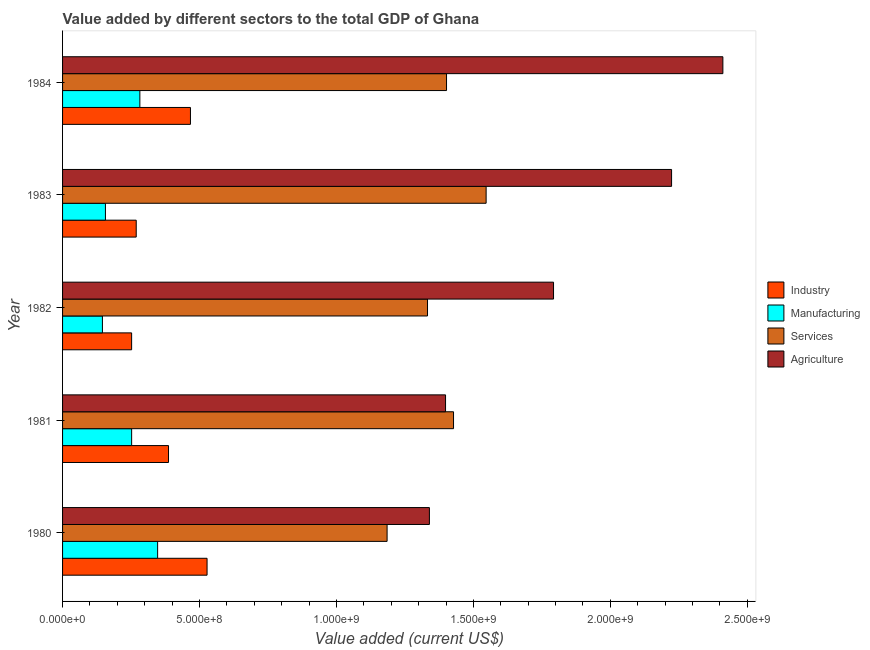How many groups of bars are there?
Ensure brevity in your answer.  5. Are the number of bars on each tick of the Y-axis equal?
Offer a terse response. Yes. How many bars are there on the 4th tick from the bottom?
Provide a short and direct response. 4. What is the label of the 4th group of bars from the top?
Your response must be concise. 1981. In how many cases, is the number of bars for a given year not equal to the number of legend labels?
Ensure brevity in your answer.  0. What is the value added by manufacturing sector in 1981?
Provide a succinct answer. 2.52e+08. Across all years, what is the maximum value added by industrial sector?
Your answer should be very brief. 5.28e+08. Across all years, what is the minimum value added by industrial sector?
Ensure brevity in your answer.  2.52e+08. In which year was the value added by agricultural sector maximum?
Your answer should be very brief. 1984. In which year was the value added by manufacturing sector minimum?
Provide a succinct answer. 1982. What is the total value added by manufacturing sector in the graph?
Make the answer very short. 1.18e+09. What is the difference between the value added by services sector in 1980 and that in 1984?
Your response must be concise. -2.17e+08. What is the difference between the value added by industrial sector in 1980 and the value added by manufacturing sector in 1983?
Give a very brief answer. 3.71e+08. What is the average value added by manufacturing sector per year?
Your response must be concise. 2.37e+08. In the year 1980, what is the difference between the value added by manufacturing sector and value added by services sector?
Your response must be concise. -8.38e+08. What is the ratio of the value added by industrial sector in 1981 to that in 1983?
Make the answer very short. 1.44. Is the value added by agricultural sector in 1982 less than that in 1983?
Offer a very short reply. Yes. Is the difference between the value added by industrial sector in 1980 and 1983 greater than the difference between the value added by services sector in 1980 and 1983?
Give a very brief answer. Yes. What is the difference between the highest and the second highest value added by services sector?
Make the answer very short. 1.19e+08. What is the difference between the highest and the lowest value added by services sector?
Provide a short and direct response. 3.62e+08. Is it the case that in every year, the sum of the value added by manufacturing sector and value added by industrial sector is greater than the sum of value added by services sector and value added by agricultural sector?
Provide a short and direct response. No. What does the 2nd bar from the top in 1980 represents?
Your response must be concise. Services. What does the 3rd bar from the bottom in 1983 represents?
Keep it short and to the point. Services. Is it the case that in every year, the sum of the value added by industrial sector and value added by manufacturing sector is greater than the value added by services sector?
Your answer should be compact. No. How many years are there in the graph?
Ensure brevity in your answer.  5. What is the difference between two consecutive major ticks on the X-axis?
Your answer should be compact. 5.00e+08. Are the values on the major ticks of X-axis written in scientific E-notation?
Offer a terse response. Yes. How many legend labels are there?
Your response must be concise. 4. What is the title of the graph?
Make the answer very short. Value added by different sectors to the total GDP of Ghana. Does "WHO" appear as one of the legend labels in the graph?
Give a very brief answer. No. What is the label or title of the X-axis?
Offer a terse response. Value added (current US$). What is the label or title of the Y-axis?
Offer a terse response. Year. What is the Value added (current US$) in Industry in 1980?
Offer a very short reply. 5.28e+08. What is the Value added (current US$) in Manufacturing in 1980?
Provide a succinct answer. 3.47e+08. What is the Value added (current US$) of Services in 1980?
Keep it short and to the point. 1.18e+09. What is the Value added (current US$) of Agriculture in 1980?
Your response must be concise. 1.34e+09. What is the Value added (current US$) of Industry in 1981?
Ensure brevity in your answer.  3.87e+08. What is the Value added (current US$) in Manufacturing in 1981?
Make the answer very short. 2.52e+08. What is the Value added (current US$) in Services in 1981?
Ensure brevity in your answer.  1.43e+09. What is the Value added (current US$) of Agriculture in 1981?
Your answer should be compact. 1.40e+09. What is the Value added (current US$) in Industry in 1982?
Ensure brevity in your answer.  2.52e+08. What is the Value added (current US$) of Manufacturing in 1982?
Give a very brief answer. 1.46e+08. What is the Value added (current US$) of Services in 1982?
Provide a succinct answer. 1.33e+09. What is the Value added (current US$) of Agriculture in 1982?
Your response must be concise. 1.79e+09. What is the Value added (current US$) of Industry in 1983?
Offer a very short reply. 2.69e+08. What is the Value added (current US$) in Manufacturing in 1983?
Your response must be concise. 1.57e+08. What is the Value added (current US$) of Services in 1983?
Ensure brevity in your answer.  1.55e+09. What is the Value added (current US$) in Agriculture in 1983?
Give a very brief answer. 2.22e+09. What is the Value added (current US$) of Industry in 1984?
Provide a short and direct response. 4.67e+08. What is the Value added (current US$) in Manufacturing in 1984?
Offer a very short reply. 2.82e+08. What is the Value added (current US$) in Services in 1984?
Provide a succinct answer. 1.40e+09. What is the Value added (current US$) in Agriculture in 1984?
Provide a succinct answer. 2.41e+09. Across all years, what is the maximum Value added (current US$) of Industry?
Provide a succinct answer. 5.28e+08. Across all years, what is the maximum Value added (current US$) of Manufacturing?
Your response must be concise. 3.47e+08. Across all years, what is the maximum Value added (current US$) of Services?
Offer a terse response. 1.55e+09. Across all years, what is the maximum Value added (current US$) of Agriculture?
Your answer should be very brief. 2.41e+09. Across all years, what is the minimum Value added (current US$) in Industry?
Keep it short and to the point. 2.52e+08. Across all years, what is the minimum Value added (current US$) of Manufacturing?
Your answer should be very brief. 1.46e+08. Across all years, what is the minimum Value added (current US$) in Services?
Give a very brief answer. 1.18e+09. Across all years, what is the minimum Value added (current US$) of Agriculture?
Ensure brevity in your answer.  1.34e+09. What is the total Value added (current US$) in Industry in the graph?
Make the answer very short. 1.90e+09. What is the total Value added (current US$) of Manufacturing in the graph?
Provide a short and direct response. 1.18e+09. What is the total Value added (current US$) of Services in the graph?
Provide a short and direct response. 6.89e+09. What is the total Value added (current US$) in Agriculture in the graph?
Your answer should be very brief. 9.16e+09. What is the difference between the Value added (current US$) of Industry in 1980 and that in 1981?
Give a very brief answer. 1.41e+08. What is the difference between the Value added (current US$) of Manufacturing in 1980 and that in 1981?
Your answer should be very brief. 9.49e+07. What is the difference between the Value added (current US$) in Services in 1980 and that in 1981?
Provide a succinct answer. -2.43e+08. What is the difference between the Value added (current US$) of Agriculture in 1980 and that in 1981?
Your answer should be very brief. -5.89e+07. What is the difference between the Value added (current US$) of Industry in 1980 and that in 1982?
Give a very brief answer. 2.75e+08. What is the difference between the Value added (current US$) in Manufacturing in 1980 and that in 1982?
Your answer should be compact. 2.02e+08. What is the difference between the Value added (current US$) in Services in 1980 and that in 1982?
Provide a short and direct response. -1.48e+08. What is the difference between the Value added (current US$) in Agriculture in 1980 and that in 1982?
Provide a succinct answer. -4.53e+08. What is the difference between the Value added (current US$) of Industry in 1980 and that in 1983?
Offer a very short reply. 2.59e+08. What is the difference between the Value added (current US$) of Manufacturing in 1980 and that in 1983?
Offer a terse response. 1.91e+08. What is the difference between the Value added (current US$) in Services in 1980 and that in 1983?
Your answer should be compact. -3.62e+08. What is the difference between the Value added (current US$) in Agriculture in 1980 and that in 1983?
Ensure brevity in your answer.  -8.84e+08. What is the difference between the Value added (current US$) of Industry in 1980 and that in 1984?
Your response must be concise. 6.07e+07. What is the difference between the Value added (current US$) of Manufacturing in 1980 and that in 1984?
Offer a terse response. 6.49e+07. What is the difference between the Value added (current US$) of Services in 1980 and that in 1984?
Provide a succinct answer. -2.17e+08. What is the difference between the Value added (current US$) in Agriculture in 1980 and that in 1984?
Ensure brevity in your answer.  -1.07e+09. What is the difference between the Value added (current US$) in Industry in 1981 and that in 1982?
Your response must be concise. 1.35e+08. What is the difference between the Value added (current US$) of Manufacturing in 1981 and that in 1982?
Your answer should be very brief. 1.07e+08. What is the difference between the Value added (current US$) of Services in 1981 and that in 1982?
Make the answer very short. 9.50e+07. What is the difference between the Value added (current US$) in Agriculture in 1981 and that in 1982?
Ensure brevity in your answer.  -3.94e+08. What is the difference between the Value added (current US$) of Industry in 1981 and that in 1983?
Keep it short and to the point. 1.18e+08. What is the difference between the Value added (current US$) of Manufacturing in 1981 and that in 1983?
Ensure brevity in your answer.  9.57e+07. What is the difference between the Value added (current US$) of Services in 1981 and that in 1983?
Keep it short and to the point. -1.19e+08. What is the difference between the Value added (current US$) in Agriculture in 1981 and that in 1983?
Make the answer very short. -8.25e+08. What is the difference between the Value added (current US$) in Industry in 1981 and that in 1984?
Give a very brief answer. -8.01e+07. What is the difference between the Value added (current US$) in Manufacturing in 1981 and that in 1984?
Offer a very short reply. -3.00e+07. What is the difference between the Value added (current US$) of Services in 1981 and that in 1984?
Keep it short and to the point. 2.55e+07. What is the difference between the Value added (current US$) of Agriculture in 1981 and that in 1984?
Keep it short and to the point. -1.01e+09. What is the difference between the Value added (current US$) of Industry in 1982 and that in 1983?
Ensure brevity in your answer.  -1.68e+07. What is the difference between the Value added (current US$) in Manufacturing in 1982 and that in 1983?
Provide a short and direct response. -1.10e+07. What is the difference between the Value added (current US$) of Services in 1982 and that in 1983?
Offer a very short reply. -2.14e+08. What is the difference between the Value added (current US$) in Agriculture in 1982 and that in 1983?
Make the answer very short. -4.31e+08. What is the difference between the Value added (current US$) of Industry in 1982 and that in 1984?
Keep it short and to the point. -2.15e+08. What is the difference between the Value added (current US$) of Manufacturing in 1982 and that in 1984?
Your answer should be compact. -1.37e+08. What is the difference between the Value added (current US$) of Services in 1982 and that in 1984?
Provide a short and direct response. -6.95e+07. What is the difference between the Value added (current US$) in Agriculture in 1982 and that in 1984?
Keep it short and to the point. -6.18e+08. What is the difference between the Value added (current US$) in Industry in 1983 and that in 1984?
Keep it short and to the point. -1.98e+08. What is the difference between the Value added (current US$) in Manufacturing in 1983 and that in 1984?
Provide a short and direct response. -1.26e+08. What is the difference between the Value added (current US$) of Services in 1983 and that in 1984?
Ensure brevity in your answer.  1.45e+08. What is the difference between the Value added (current US$) in Agriculture in 1983 and that in 1984?
Your answer should be compact. -1.87e+08. What is the difference between the Value added (current US$) of Industry in 1980 and the Value added (current US$) of Manufacturing in 1981?
Keep it short and to the point. 2.75e+08. What is the difference between the Value added (current US$) in Industry in 1980 and the Value added (current US$) in Services in 1981?
Provide a succinct answer. -9.00e+08. What is the difference between the Value added (current US$) of Industry in 1980 and the Value added (current US$) of Agriculture in 1981?
Keep it short and to the point. -8.71e+08. What is the difference between the Value added (current US$) of Manufacturing in 1980 and the Value added (current US$) of Services in 1981?
Ensure brevity in your answer.  -1.08e+09. What is the difference between the Value added (current US$) of Manufacturing in 1980 and the Value added (current US$) of Agriculture in 1981?
Your response must be concise. -1.05e+09. What is the difference between the Value added (current US$) of Services in 1980 and the Value added (current US$) of Agriculture in 1981?
Provide a succinct answer. -2.13e+08. What is the difference between the Value added (current US$) of Industry in 1980 and the Value added (current US$) of Manufacturing in 1982?
Make the answer very short. 3.82e+08. What is the difference between the Value added (current US$) of Industry in 1980 and the Value added (current US$) of Services in 1982?
Keep it short and to the point. -8.05e+08. What is the difference between the Value added (current US$) of Industry in 1980 and the Value added (current US$) of Agriculture in 1982?
Make the answer very short. -1.26e+09. What is the difference between the Value added (current US$) in Manufacturing in 1980 and the Value added (current US$) in Services in 1982?
Your answer should be very brief. -9.85e+08. What is the difference between the Value added (current US$) in Manufacturing in 1980 and the Value added (current US$) in Agriculture in 1982?
Provide a short and direct response. -1.45e+09. What is the difference between the Value added (current US$) in Services in 1980 and the Value added (current US$) in Agriculture in 1982?
Make the answer very short. -6.08e+08. What is the difference between the Value added (current US$) of Industry in 1980 and the Value added (current US$) of Manufacturing in 1983?
Provide a succinct answer. 3.71e+08. What is the difference between the Value added (current US$) in Industry in 1980 and the Value added (current US$) in Services in 1983?
Make the answer very short. -1.02e+09. What is the difference between the Value added (current US$) in Industry in 1980 and the Value added (current US$) in Agriculture in 1983?
Ensure brevity in your answer.  -1.70e+09. What is the difference between the Value added (current US$) in Manufacturing in 1980 and the Value added (current US$) in Services in 1983?
Give a very brief answer. -1.20e+09. What is the difference between the Value added (current US$) in Manufacturing in 1980 and the Value added (current US$) in Agriculture in 1983?
Your response must be concise. -1.88e+09. What is the difference between the Value added (current US$) in Services in 1980 and the Value added (current US$) in Agriculture in 1983?
Make the answer very short. -1.04e+09. What is the difference between the Value added (current US$) in Industry in 1980 and the Value added (current US$) in Manufacturing in 1984?
Provide a succinct answer. 2.45e+08. What is the difference between the Value added (current US$) of Industry in 1980 and the Value added (current US$) of Services in 1984?
Provide a short and direct response. -8.74e+08. What is the difference between the Value added (current US$) of Industry in 1980 and the Value added (current US$) of Agriculture in 1984?
Your answer should be very brief. -1.88e+09. What is the difference between the Value added (current US$) of Manufacturing in 1980 and the Value added (current US$) of Services in 1984?
Make the answer very short. -1.05e+09. What is the difference between the Value added (current US$) of Manufacturing in 1980 and the Value added (current US$) of Agriculture in 1984?
Make the answer very short. -2.06e+09. What is the difference between the Value added (current US$) in Services in 1980 and the Value added (current US$) in Agriculture in 1984?
Your answer should be compact. -1.23e+09. What is the difference between the Value added (current US$) in Industry in 1981 and the Value added (current US$) in Manufacturing in 1982?
Offer a terse response. 2.41e+08. What is the difference between the Value added (current US$) in Industry in 1981 and the Value added (current US$) in Services in 1982?
Your answer should be very brief. -9.46e+08. What is the difference between the Value added (current US$) in Industry in 1981 and the Value added (current US$) in Agriculture in 1982?
Your answer should be compact. -1.41e+09. What is the difference between the Value added (current US$) in Manufacturing in 1981 and the Value added (current US$) in Services in 1982?
Your answer should be compact. -1.08e+09. What is the difference between the Value added (current US$) in Manufacturing in 1981 and the Value added (current US$) in Agriculture in 1982?
Your answer should be very brief. -1.54e+09. What is the difference between the Value added (current US$) of Services in 1981 and the Value added (current US$) of Agriculture in 1982?
Offer a terse response. -3.65e+08. What is the difference between the Value added (current US$) in Industry in 1981 and the Value added (current US$) in Manufacturing in 1983?
Your answer should be compact. 2.30e+08. What is the difference between the Value added (current US$) of Industry in 1981 and the Value added (current US$) of Services in 1983?
Keep it short and to the point. -1.16e+09. What is the difference between the Value added (current US$) in Industry in 1981 and the Value added (current US$) in Agriculture in 1983?
Your answer should be compact. -1.84e+09. What is the difference between the Value added (current US$) of Manufacturing in 1981 and the Value added (current US$) of Services in 1983?
Your answer should be compact. -1.29e+09. What is the difference between the Value added (current US$) in Manufacturing in 1981 and the Value added (current US$) in Agriculture in 1983?
Your response must be concise. -1.97e+09. What is the difference between the Value added (current US$) of Services in 1981 and the Value added (current US$) of Agriculture in 1983?
Give a very brief answer. -7.96e+08. What is the difference between the Value added (current US$) of Industry in 1981 and the Value added (current US$) of Manufacturing in 1984?
Provide a succinct answer. 1.05e+08. What is the difference between the Value added (current US$) in Industry in 1981 and the Value added (current US$) in Services in 1984?
Make the answer very short. -1.02e+09. What is the difference between the Value added (current US$) in Industry in 1981 and the Value added (current US$) in Agriculture in 1984?
Your answer should be compact. -2.02e+09. What is the difference between the Value added (current US$) in Manufacturing in 1981 and the Value added (current US$) in Services in 1984?
Provide a succinct answer. -1.15e+09. What is the difference between the Value added (current US$) of Manufacturing in 1981 and the Value added (current US$) of Agriculture in 1984?
Your answer should be compact. -2.16e+09. What is the difference between the Value added (current US$) in Services in 1981 and the Value added (current US$) in Agriculture in 1984?
Provide a succinct answer. -9.83e+08. What is the difference between the Value added (current US$) in Industry in 1982 and the Value added (current US$) in Manufacturing in 1983?
Provide a succinct answer. 9.56e+07. What is the difference between the Value added (current US$) in Industry in 1982 and the Value added (current US$) in Services in 1983?
Offer a terse response. -1.29e+09. What is the difference between the Value added (current US$) in Industry in 1982 and the Value added (current US$) in Agriculture in 1983?
Offer a very short reply. -1.97e+09. What is the difference between the Value added (current US$) in Manufacturing in 1982 and the Value added (current US$) in Services in 1983?
Your answer should be very brief. -1.40e+09. What is the difference between the Value added (current US$) in Manufacturing in 1982 and the Value added (current US$) in Agriculture in 1983?
Offer a terse response. -2.08e+09. What is the difference between the Value added (current US$) of Services in 1982 and the Value added (current US$) of Agriculture in 1983?
Give a very brief answer. -8.91e+08. What is the difference between the Value added (current US$) of Industry in 1982 and the Value added (current US$) of Manufacturing in 1984?
Make the answer very short. -3.01e+07. What is the difference between the Value added (current US$) in Industry in 1982 and the Value added (current US$) in Services in 1984?
Your response must be concise. -1.15e+09. What is the difference between the Value added (current US$) in Industry in 1982 and the Value added (current US$) in Agriculture in 1984?
Ensure brevity in your answer.  -2.16e+09. What is the difference between the Value added (current US$) in Manufacturing in 1982 and the Value added (current US$) in Services in 1984?
Provide a succinct answer. -1.26e+09. What is the difference between the Value added (current US$) in Manufacturing in 1982 and the Value added (current US$) in Agriculture in 1984?
Offer a very short reply. -2.27e+09. What is the difference between the Value added (current US$) in Services in 1982 and the Value added (current US$) in Agriculture in 1984?
Make the answer very short. -1.08e+09. What is the difference between the Value added (current US$) of Industry in 1983 and the Value added (current US$) of Manufacturing in 1984?
Provide a short and direct response. -1.33e+07. What is the difference between the Value added (current US$) in Industry in 1983 and the Value added (current US$) in Services in 1984?
Provide a short and direct response. -1.13e+09. What is the difference between the Value added (current US$) in Industry in 1983 and the Value added (current US$) in Agriculture in 1984?
Provide a short and direct response. -2.14e+09. What is the difference between the Value added (current US$) in Manufacturing in 1983 and the Value added (current US$) in Services in 1984?
Keep it short and to the point. -1.25e+09. What is the difference between the Value added (current US$) in Manufacturing in 1983 and the Value added (current US$) in Agriculture in 1984?
Your answer should be very brief. -2.25e+09. What is the difference between the Value added (current US$) of Services in 1983 and the Value added (current US$) of Agriculture in 1984?
Your answer should be very brief. -8.64e+08. What is the average Value added (current US$) of Industry per year?
Make the answer very short. 3.80e+08. What is the average Value added (current US$) of Manufacturing per year?
Provide a succinct answer. 2.37e+08. What is the average Value added (current US$) in Services per year?
Offer a terse response. 1.38e+09. What is the average Value added (current US$) in Agriculture per year?
Your response must be concise. 1.83e+09. In the year 1980, what is the difference between the Value added (current US$) in Industry and Value added (current US$) in Manufacturing?
Provide a short and direct response. 1.80e+08. In the year 1980, what is the difference between the Value added (current US$) of Industry and Value added (current US$) of Services?
Give a very brief answer. -6.57e+08. In the year 1980, what is the difference between the Value added (current US$) in Industry and Value added (current US$) in Agriculture?
Offer a very short reply. -8.12e+08. In the year 1980, what is the difference between the Value added (current US$) of Manufacturing and Value added (current US$) of Services?
Offer a very short reply. -8.38e+08. In the year 1980, what is the difference between the Value added (current US$) of Manufacturing and Value added (current US$) of Agriculture?
Make the answer very short. -9.92e+08. In the year 1980, what is the difference between the Value added (current US$) of Services and Value added (current US$) of Agriculture?
Your answer should be compact. -1.55e+08. In the year 1981, what is the difference between the Value added (current US$) of Industry and Value added (current US$) of Manufacturing?
Give a very brief answer. 1.35e+08. In the year 1981, what is the difference between the Value added (current US$) in Industry and Value added (current US$) in Services?
Offer a very short reply. -1.04e+09. In the year 1981, what is the difference between the Value added (current US$) of Industry and Value added (current US$) of Agriculture?
Keep it short and to the point. -1.01e+09. In the year 1981, what is the difference between the Value added (current US$) in Manufacturing and Value added (current US$) in Services?
Make the answer very short. -1.18e+09. In the year 1981, what is the difference between the Value added (current US$) in Manufacturing and Value added (current US$) in Agriculture?
Ensure brevity in your answer.  -1.15e+09. In the year 1981, what is the difference between the Value added (current US$) in Services and Value added (current US$) in Agriculture?
Make the answer very short. 2.91e+07. In the year 1982, what is the difference between the Value added (current US$) of Industry and Value added (current US$) of Manufacturing?
Your answer should be very brief. 1.07e+08. In the year 1982, what is the difference between the Value added (current US$) in Industry and Value added (current US$) in Services?
Provide a short and direct response. -1.08e+09. In the year 1982, what is the difference between the Value added (current US$) of Industry and Value added (current US$) of Agriculture?
Offer a very short reply. -1.54e+09. In the year 1982, what is the difference between the Value added (current US$) of Manufacturing and Value added (current US$) of Services?
Your response must be concise. -1.19e+09. In the year 1982, what is the difference between the Value added (current US$) of Manufacturing and Value added (current US$) of Agriculture?
Offer a very short reply. -1.65e+09. In the year 1982, what is the difference between the Value added (current US$) in Services and Value added (current US$) in Agriculture?
Make the answer very short. -4.60e+08. In the year 1983, what is the difference between the Value added (current US$) of Industry and Value added (current US$) of Manufacturing?
Your answer should be compact. 1.12e+08. In the year 1983, what is the difference between the Value added (current US$) in Industry and Value added (current US$) in Services?
Your response must be concise. -1.28e+09. In the year 1983, what is the difference between the Value added (current US$) of Industry and Value added (current US$) of Agriculture?
Your response must be concise. -1.95e+09. In the year 1983, what is the difference between the Value added (current US$) in Manufacturing and Value added (current US$) in Services?
Ensure brevity in your answer.  -1.39e+09. In the year 1983, what is the difference between the Value added (current US$) of Manufacturing and Value added (current US$) of Agriculture?
Your response must be concise. -2.07e+09. In the year 1983, what is the difference between the Value added (current US$) in Services and Value added (current US$) in Agriculture?
Your answer should be compact. -6.77e+08. In the year 1984, what is the difference between the Value added (current US$) in Industry and Value added (current US$) in Manufacturing?
Ensure brevity in your answer.  1.85e+08. In the year 1984, what is the difference between the Value added (current US$) in Industry and Value added (current US$) in Services?
Offer a terse response. -9.35e+08. In the year 1984, what is the difference between the Value added (current US$) of Industry and Value added (current US$) of Agriculture?
Your response must be concise. -1.94e+09. In the year 1984, what is the difference between the Value added (current US$) of Manufacturing and Value added (current US$) of Services?
Your response must be concise. -1.12e+09. In the year 1984, what is the difference between the Value added (current US$) in Manufacturing and Value added (current US$) in Agriculture?
Your response must be concise. -2.13e+09. In the year 1984, what is the difference between the Value added (current US$) of Services and Value added (current US$) of Agriculture?
Offer a very short reply. -1.01e+09. What is the ratio of the Value added (current US$) of Industry in 1980 to that in 1981?
Keep it short and to the point. 1.36. What is the ratio of the Value added (current US$) in Manufacturing in 1980 to that in 1981?
Ensure brevity in your answer.  1.38. What is the ratio of the Value added (current US$) of Services in 1980 to that in 1981?
Keep it short and to the point. 0.83. What is the ratio of the Value added (current US$) in Agriculture in 1980 to that in 1981?
Provide a short and direct response. 0.96. What is the ratio of the Value added (current US$) in Industry in 1980 to that in 1982?
Keep it short and to the point. 2.09. What is the ratio of the Value added (current US$) in Manufacturing in 1980 to that in 1982?
Make the answer very short. 2.39. What is the ratio of the Value added (current US$) in Services in 1980 to that in 1982?
Your response must be concise. 0.89. What is the ratio of the Value added (current US$) of Agriculture in 1980 to that in 1982?
Ensure brevity in your answer.  0.75. What is the ratio of the Value added (current US$) in Industry in 1980 to that in 1983?
Your response must be concise. 1.96. What is the ratio of the Value added (current US$) in Manufacturing in 1980 to that in 1983?
Your answer should be compact. 2.22. What is the ratio of the Value added (current US$) of Services in 1980 to that in 1983?
Make the answer very short. 0.77. What is the ratio of the Value added (current US$) in Agriculture in 1980 to that in 1983?
Keep it short and to the point. 0.6. What is the ratio of the Value added (current US$) in Industry in 1980 to that in 1984?
Offer a terse response. 1.13. What is the ratio of the Value added (current US$) of Manufacturing in 1980 to that in 1984?
Your answer should be very brief. 1.23. What is the ratio of the Value added (current US$) in Services in 1980 to that in 1984?
Offer a very short reply. 0.85. What is the ratio of the Value added (current US$) of Agriculture in 1980 to that in 1984?
Offer a terse response. 0.56. What is the ratio of the Value added (current US$) of Industry in 1981 to that in 1982?
Your response must be concise. 1.53. What is the ratio of the Value added (current US$) of Manufacturing in 1981 to that in 1982?
Ensure brevity in your answer.  1.73. What is the ratio of the Value added (current US$) in Services in 1981 to that in 1982?
Ensure brevity in your answer.  1.07. What is the ratio of the Value added (current US$) in Agriculture in 1981 to that in 1982?
Make the answer very short. 0.78. What is the ratio of the Value added (current US$) of Industry in 1981 to that in 1983?
Your answer should be compact. 1.44. What is the ratio of the Value added (current US$) in Manufacturing in 1981 to that in 1983?
Provide a short and direct response. 1.61. What is the ratio of the Value added (current US$) in Services in 1981 to that in 1983?
Keep it short and to the point. 0.92. What is the ratio of the Value added (current US$) of Agriculture in 1981 to that in 1983?
Offer a terse response. 0.63. What is the ratio of the Value added (current US$) of Industry in 1981 to that in 1984?
Provide a short and direct response. 0.83. What is the ratio of the Value added (current US$) in Manufacturing in 1981 to that in 1984?
Your answer should be very brief. 0.89. What is the ratio of the Value added (current US$) of Services in 1981 to that in 1984?
Give a very brief answer. 1.02. What is the ratio of the Value added (current US$) of Agriculture in 1981 to that in 1984?
Provide a short and direct response. 0.58. What is the ratio of the Value added (current US$) in Industry in 1982 to that in 1983?
Offer a very short reply. 0.94. What is the ratio of the Value added (current US$) of Manufacturing in 1982 to that in 1983?
Offer a very short reply. 0.93. What is the ratio of the Value added (current US$) in Services in 1982 to that in 1983?
Your answer should be compact. 0.86. What is the ratio of the Value added (current US$) in Agriculture in 1982 to that in 1983?
Provide a succinct answer. 0.81. What is the ratio of the Value added (current US$) in Industry in 1982 to that in 1984?
Ensure brevity in your answer.  0.54. What is the ratio of the Value added (current US$) of Manufacturing in 1982 to that in 1984?
Ensure brevity in your answer.  0.52. What is the ratio of the Value added (current US$) of Services in 1982 to that in 1984?
Give a very brief answer. 0.95. What is the ratio of the Value added (current US$) in Agriculture in 1982 to that in 1984?
Make the answer very short. 0.74. What is the ratio of the Value added (current US$) of Industry in 1983 to that in 1984?
Make the answer very short. 0.58. What is the ratio of the Value added (current US$) in Manufacturing in 1983 to that in 1984?
Keep it short and to the point. 0.55. What is the ratio of the Value added (current US$) in Services in 1983 to that in 1984?
Offer a terse response. 1.1. What is the ratio of the Value added (current US$) in Agriculture in 1983 to that in 1984?
Provide a short and direct response. 0.92. What is the difference between the highest and the second highest Value added (current US$) of Industry?
Your answer should be very brief. 6.07e+07. What is the difference between the highest and the second highest Value added (current US$) of Manufacturing?
Offer a terse response. 6.49e+07. What is the difference between the highest and the second highest Value added (current US$) in Services?
Offer a terse response. 1.19e+08. What is the difference between the highest and the second highest Value added (current US$) of Agriculture?
Give a very brief answer. 1.87e+08. What is the difference between the highest and the lowest Value added (current US$) in Industry?
Provide a short and direct response. 2.75e+08. What is the difference between the highest and the lowest Value added (current US$) of Manufacturing?
Provide a short and direct response. 2.02e+08. What is the difference between the highest and the lowest Value added (current US$) in Services?
Offer a terse response. 3.62e+08. What is the difference between the highest and the lowest Value added (current US$) in Agriculture?
Give a very brief answer. 1.07e+09. 